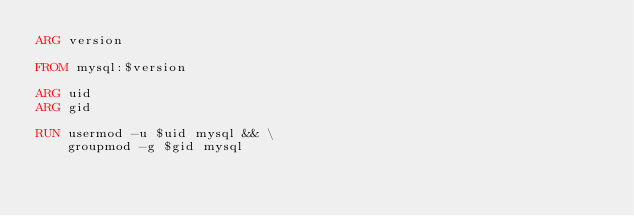<code> <loc_0><loc_0><loc_500><loc_500><_Dockerfile_>ARG version

FROM mysql:$version

ARG uid
ARG gid

RUN usermod -u $uid mysql && \
    groupmod -g $gid mysql</code> 